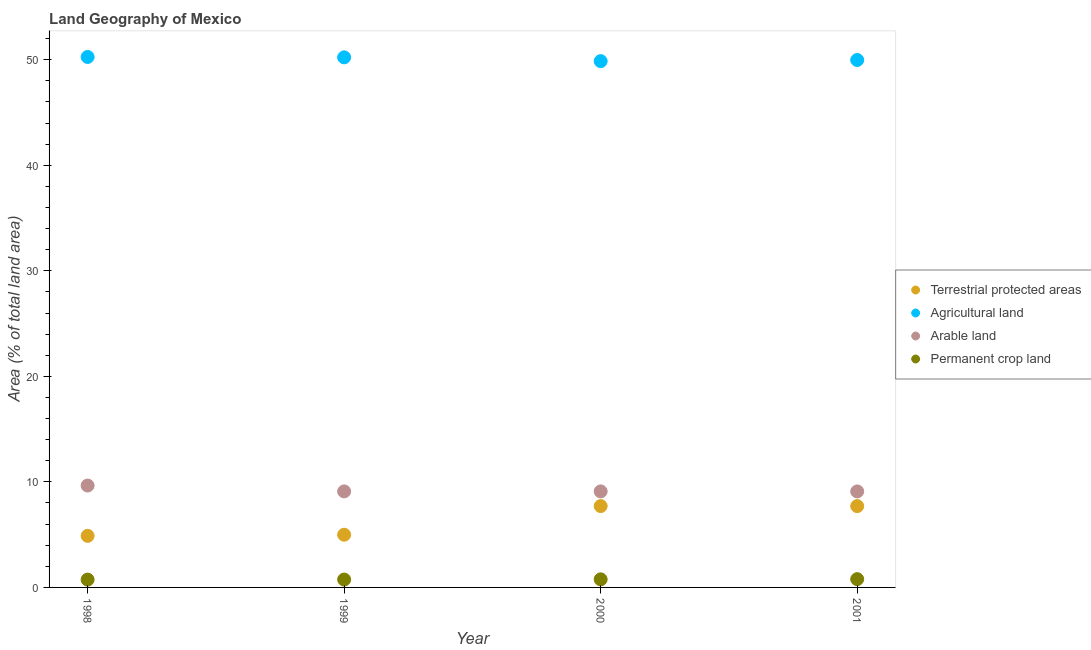How many different coloured dotlines are there?
Keep it short and to the point. 4. What is the percentage of area under agricultural land in 2001?
Provide a succinct answer. 49.98. Across all years, what is the maximum percentage of land under terrestrial protection?
Keep it short and to the point. 7.71. Across all years, what is the minimum percentage of land under terrestrial protection?
Offer a terse response. 4.89. What is the total percentage of area under permanent crop land in the graph?
Give a very brief answer. 3.04. What is the difference between the percentage of land under terrestrial protection in 1998 and that in 1999?
Your response must be concise. -0.11. What is the difference between the percentage of area under arable land in 1998 and the percentage of land under terrestrial protection in 2000?
Your response must be concise. 1.95. What is the average percentage of land under terrestrial protection per year?
Your response must be concise. 6.32. In the year 2000, what is the difference between the percentage of area under agricultural land and percentage of land under terrestrial protection?
Provide a succinct answer. 42.16. What is the ratio of the percentage of area under permanent crop land in 2000 to that in 2001?
Your answer should be very brief. 0.98. Is the percentage of land under terrestrial protection in 1998 less than that in 2001?
Your answer should be compact. Yes. What is the difference between the highest and the second highest percentage of area under arable land?
Your response must be concise. 0.56. What is the difference between the highest and the lowest percentage of area under agricultural land?
Provide a short and direct response. 0.4. In how many years, is the percentage of area under permanent crop land greater than the average percentage of area under permanent crop land taken over all years?
Give a very brief answer. 2. Is it the case that in every year, the sum of the percentage of area under permanent crop land and percentage of area under agricultural land is greater than the sum of percentage of land under terrestrial protection and percentage of area under arable land?
Provide a succinct answer. Yes. Is it the case that in every year, the sum of the percentage of land under terrestrial protection and percentage of area under agricultural land is greater than the percentage of area under arable land?
Provide a short and direct response. Yes. Does the percentage of land under terrestrial protection monotonically increase over the years?
Make the answer very short. No. Is the percentage of land under terrestrial protection strictly less than the percentage of area under permanent crop land over the years?
Ensure brevity in your answer.  No. How many dotlines are there?
Provide a short and direct response. 4. How many years are there in the graph?
Give a very brief answer. 4. What is the difference between two consecutive major ticks on the Y-axis?
Keep it short and to the point. 10. Are the values on the major ticks of Y-axis written in scientific E-notation?
Offer a very short reply. No. Does the graph contain any zero values?
Give a very brief answer. No. How are the legend labels stacked?
Keep it short and to the point. Vertical. What is the title of the graph?
Offer a very short reply. Land Geography of Mexico. What is the label or title of the X-axis?
Ensure brevity in your answer.  Year. What is the label or title of the Y-axis?
Provide a succinct answer. Area (% of total land area). What is the Area (% of total land area) in Terrestrial protected areas in 1998?
Offer a very short reply. 4.89. What is the Area (% of total land area) of Agricultural land in 1998?
Make the answer very short. 50.26. What is the Area (% of total land area) of Arable land in 1998?
Give a very brief answer. 9.66. What is the Area (% of total land area) of Permanent crop land in 1998?
Your response must be concise. 0.74. What is the Area (% of total land area) of Terrestrial protected areas in 1999?
Your answer should be very brief. 4.99. What is the Area (% of total land area) of Agricultural land in 1999?
Provide a succinct answer. 50.23. What is the Area (% of total land area) in Arable land in 1999?
Offer a very short reply. 9.1. What is the Area (% of total land area) of Permanent crop land in 1999?
Your answer should be very brief. 0.75. What is the Area (% of total land area) of Terrestrial protected areas in 2000?
Your answer should be very brief. 7.71. What is the Area (% of total land area) in Agricultural land in 2000?
Your answer should be very brief. 49.87. What is the Area (% of total land area) in Arable land in 2000?
Provide a succinct answer. 9.1. What is the Area (% of total land area) in Permanent crop land in 2000?
Ensure brevity in your answer.  0.77. What is the Area (% of total land area) of Terrestrial protected areas in 2001?
Provide a succinct answer. 7.7. What is the Area (% of total land area) in Agricultural land in 2001?
Make the answer very short. 49.98. What is the Area (% of total land area) of Arable land in 2001?
Offer a very short reply. 9.1. What is the Area (% of total land area) of Permanent crop land in 2001?
Provide a short and direct response. 0.78. Across all years, what is the maximum Area (% of total land area) in Terrestrial protected areas?
Provide a succinct answer. 7.71. Across all years, what is the maximum Area (% of total land area) in Agricultural land?
Ensure brevity in your answer.  50.26. Across all years, what is the maximum Area (% of total land area) of Arable land?
Provide a short and direct response. 9.66. Across all years, what is the maximum Area (% of total land area) in Permanent crop land?
Ensure brevity in your answer.  0.78. Across all years, what is the minimum Area (% of total land area) of Terrestrial protected areas?
Give a very brief answer. 4.89. Across all years, what is the minimum Area (% of total land area) of Agricultural land?
Offer a terse response. 49.87. Across all years, what is the minimum Area (% of total land area) in Arable land?
Offer a very short reply. 9.1. Across all years, what is the minimum Area (% of total land area) of Permanent crop land?
Your answer should be very brief. 0.74. What is the total Area (% of total land area) of Terrestrial protected areas in the graph?
Offer a terse response. 25.3. What is the total Area (% of total land area) in Agricultural land in the graph?
Your response must be concise. 200.33. What is the total Area (% of total land area) in Arable land in the graph?
Your answer should be very brief. 36.95. What is the total Area (% of total land area) of Permanent crop land in the graph?
Offer a terse response. 3.04. What is the difference between the Area (% of total land area) in Terrestrial protected areas in 1998 and that in 1999?
Your response must be concise. -0.11. What is the difference between the Area (% of total land area) of Agricultural land in 1998 and that in 1999?
Offer a terse response. 0.04. What is the difference between the Area (% of total land area) in Arable land in 1998 and that in 1999?
Ensure brevity in your answer.  0.56. What is the difference between the Area (% of total land area) of Permanent crop land in 1998 and that in 1999?
Ensure brevity in your answer.  -0.01. What is the difference between the Area (% of total land area) of Terrestrial protected areas in 1998 and that in 2000?
Make the answer very short. -2.82. What is the difference between the Area (% of total land area) of Agricultural land in 1998 and that in 2000?
Your response must be concise. 0.4. What is the difference between the Area (% of total land area) of Arable land in 1998 and that in 2000?
Make the answer very short. 0.56. What is the difference between the Area (% of total land area) in Permanent crop land in 1998 and that in 2000?
Make the answer very short. -0.03. What is the difference between the Area (% of total land area) of Terrestrial protected areas in 1998 and that in 2001?
Keep it short and to the point. -2.82. What is the difference between the Area (% of total land area) of Agricultural land in 1998 and that in 2001?
Your answer should be very brief. 0.29. What is the difference between the Area (% of total land area) in Arable land in 1998 and that in 2001?
Ensure brevity in your answer.  0.56. What is the difference between the Area (% of total land area) of Permanent crop land in 1998 and that in 2001?
Offer a terse response. -0.04. What is the difference between the Area (% of total land area) in Terrestrial protected areas in 1999 and that in 2000?
Keep it short and to the point. -2.72. What is the difference between the Area (% of total land area) of Agricultural land in 1999 and that in 2000?
Keep it short and to the point. 0.36. What is the difference between the Area (% of total land area) of Arable land in 1999 and that in 2000?
Offer a very short reply. -0. What is the difference between the Area (% of total land area) in Permanent crop land in 1999 and that in 2000?
Provide a short and direct response. -0.02. What is the difference between the Area (% of total land area) of Terrestrial protected areas in 1999 and that in 2001?
Make the answer very short. -2.71. What is the difference between the Area (% of total land area) in Agricultural land in 1999 and that in 2001?
Your response must be concise. 0.25. What is the difference between the Area (% of total land area) of Arable land in 1999 and that in 2001?
Offer a very short reply. 0. What is the difference between the Area (% of total land area) of Permanent crop land in 1999 and that in 2001?
Your answer should be very brief. -0.04. What is the difference between the Area (% of total land area) in Terrestrial protected areas in 2000 and that in 2001?
Your response must be concise. 0.01. What is the difference between the Area (% of total land area) in Agricultural land in 2000 and that in 2001?
Give a very brief answer. -0.11. What is the difference between the Area (% of total land area) in Arable land in 2000 and that in 2001?
Make the answer very short. 0. What is the difference between the Area (% of total land area) in Permanent crop land in 2000 and that in 2001?
Make the answer very short. -0.02. What is the difference between the Area (% of total land area) of Terrestrial protected areas in 1998 and the Area (% of total land area) of Agricultural land in 1999?
Keep it short and to the point. -45.34. What is the difference between the Area (% of total land area) in Terrestrial protected areas in 1998 and the Area (% of total land area) in Arable land in 1999?
Offer a terse response. -4.21. What is the difference between the Area (% of total land area) of Terrestrial protected areas in 1998 and the Area (% of total land area) of Permanent crop land in 1999?
Offer a very short reply. 4.14. What is the difference between the Area (% of total land area) of Agricultural land in 1998 and the Area (% of total land area) of Arable land in 1999?
Offer a very short reply. 41.16. What is the difference between the Area (% of total land area) of Agricultural land in 1998 and the Area (% of total land area) of Permanent crop land in 1999?
Provide a succinct answer. 49.52. What is the difference between the Area (% of total land area) of Arable land in 1998 and the Area (% of total land area) of Permanent crop land in 1999?
Offer a terse response. 8.91. What is the difference between the Area (% of total land area) in Terrestrial protected areas in 1998 and the Area (% of total land area) in Agricultural land in 2000?
Provide a succinct answer. -44.98. What is the difference between the Area (% of total land area) in Terrestrial protected areas in 1998 and the Area (% of total land area) in Arable land in 2000?
Give a very brief answer. -4.21. What is the difference between the Area (% of total land area) of Terrestrial protected areas in 1998 and the Area (% of total land area) of Permanent crop land in 2000?
Provide a succinct answer. 4.12. What is the difference between the Area (% of total land area) of Agricultural land in 1998 and the Area (% of total land area) of Arable land in 2000?
Keep it short and to the point. 41.16. What is the difference between the Area (% of total land area) in Agricultural land in 1998 and the Area (% of total land area) in Permanent crop land in 2000?
Offer a terse response. 49.5. What is the difference between the Area (% of total land area) of Arable land in 1998 and the Area (% of total land area) of Permanent crop land in 2000?
Provide a short and direct response. 8.89. What is the difference between the Area (% of total land area) in Terrestrial protected areas in 1998 and the Area (% of total land area) in Agricultural land in 2001?
Ensure brevity in your answer.  -45.09. What is the difference between the Area (% of total land area) in Terrestrial protected areas in 1998 and the Area (% of total land area) in Arable land in 2001?
Your response must be concise. -4.21. What is the difference between the Area (% of total land area) in Terrestrial protected areas in 1998 and the Area (% of total land area) in Permanent crop land in 2001?
Offer a very short reply. 4.1. What is the difference between the Area (% of total land area) of Agricultural land in 1998 and the Area (% of total land area) of Arable land in 2001?
Provide a succinct answer. 41.17. What is the difference between the Area (% of total land area) in Agricultural land in 1998 and the Area (% of total land area) in Permanent crop land in 2001?
Your response must be concise. 49.48. What is the difference between the Area (% of total land area) of Arable land in 1998 and the Area (% of total land area) of Permanent crop land in 2001?
Give a very brief answer. 8.87. What is the difference between the Area (% of total land area) of Terrestrial protected areas in 1999 and the Area (% of total land area) of Agricultural land in 2000?
Make the answer very short. -44.87. What is the difference between the Area (% of total land area) in Terrestrial protected areas in 1999 and the Area (% of total land area) in Arable land in 2000?
Your answer should be very brief. -4.11. What is the difference between the Area (% of total land area) in Terrestrial protected areas in 1999 and the Area (% of total land area) in Permanent crop land in 2000?
Offer a terse response. 4.23. What is the difference between the Area (% of total land area) in Agricultural land in 1999 and the Area (% of total land area) in Arable land in 2000?
Offer a very short reply. 41.13. What is the difference between the Area (% of total land area) in Agricultural land in 1999 and the Area (% of total land area) in Permanent crop land in 2000?
Keep it short and to the point. 49.46. What is the difference between the Area (% of total land area) in Arable land in 1999 and the Area (% of total land area) in Permanent crop land in 2000?
Keep it short and to the point. 8.33. What is the difference between the Area (% of total land area) of Terrestrial protected areas in 1999 and the Area (% of total land area) of Agricultural land in 2001?
Offer a very short reply. -44.98. What is the difference between the Area (% of total land area) of Terrestrial protected areas in 1999 and the Area (% of total land area) of Arable land in 2001?
Ensure brevity in your answer.  -4.1. What is the difference between the Area (% of total land area) in Terrestrial protected areas in 1999 and the Area (% of total land area) in Permanent crop land in 2001?
Keep it short and to the point. 4.21. What is the difference between the Area (% of total land area) of Agricultural land in 1999 and the Area (% of total land area) of Arable land in 2001?
Your answer should be compact. 41.13. What is the difference between the Area (% of total land area) in Agricultural land in 1999 and the Area (% of total land area) in Permanent crop land in 2001?
Your answer should be very brief. 49.44. What is the difference between the Area (% of total land area) of Arable land in 1999 and the Area (% of total land area) of Permanent crop land in 2001?
Give a very brief answer. 8.31. What is the difference between the Area (% of total land area) of Terrestrial protected areas in 2000 and the Area (% of total land area) of Agricultural land in 2001?
Your response must be concise. -42.27. What is the difference between the Area (% of total land area) of Terrestrial protected areas in 2000 and the Area (% of total land area) of Arable land in 2001?
Offer a very short reply. -1.39. What is the difference between the Area (% of total land area) in Terrestrial protected areas in 2000 and the Area (% of total land area) in Permanent crop land in 2001?
Your answer should be very brief. 6.93. What is the difference between the Area (% of total land area) of Agricultural land in 2000 and the Area (% of total land area) of Arable land in 2001?
Offer a terse response. 40.77. What is the difference between the Area (% of total land area) of Agricultural land in 2000 and the Area (% of total land area) of Permanent crop land in 2001?
Offer a very short reply. 49.08. What is the difference between the Area (% of total land area) in Arable land in 2000 and the Area (% of total land area) in Permanent crop land in 2001?
Your response must be concise. 8.31. What is the average Area (% of total land area) of Terrestrial protected areas per year?
Offer a terse response. 6.32. What is the average Area (% of total land area) of Agricultural land per year?
Provide a succinct answer. 50.08. What is the average Area (% of total land area) in Arable land per year?
Your answer should be very brief. 9.24. What is the average Area (% of total land area) of Permanent crop land per year?
Offer a terse response. 0.76. In the year 1998, what is the difference between the Area (% of total land area) in Terrestrial protected areas and Area (% of total land area) in Agricultural land?
Give a very brief answer. -45.38. In the year 1998, what is the difference between the Area (% of total land area) in Terrestrial protected areas and Area (% of total land area) in Arable land?
Offer a terse response. -4.77. In the year 1998, what is the difference between the Area (% of total land area) of Terrestrial protected areas and Area (% of total land area) of Permanent crop land?
Give a very brief answer. 4.15. In the year 1998, what is the difference between the Area (% of total land area) in Agricultural land and Area (% of total land area) in Arable land?
Keep it short and to the point. 40.61. In the year 1998, what is the difference between the Area (% of total land area) of Agricultural land and Area (% of total land area) of Permanent crop land?
Your answer should be compact. 49.52. In the year 1998, what is the difference between the Area (% of total land area) in Arable land and Area (% of total land area) in Permanent crop land?
Offer a terse response. 8.91. In the year 1999, what is the difference between the Area (% of total land area) in Terrestrial protected areas and Area (% of total land area) in Agricultural land?
Provide a short and direct response. -45.23. In the year 1999, what is the difference between the Area (% of total land area) of Terrestrial protected areas and Area (% of total land area) of Arable land?
Ensure brevity in your answer.  -4.11. In the year 1999, what is the difference between the Area (% of total land area) in Terrestrial protected areas and Area (% of total land area) in Permanent crop land?
Provide a succinct answer. 4.25. In the year 1999, what is the difference between the Area (% of total land area) of Agricultural land and Area (% of total land area) of Arable land?
Provide a short and direct response. 41.13. In the year 1999, what is the difference between the Area (% of total land area) of Agricultural land and Area (% of total land area) of Permanent crop land?
Keep it short and to the point. 49.48. In the year 1999, what is the difference between the Area (% of total land area) in Arable land and Area (% of total land area) in Permanent crop land?
Keep it short and to the point. 8.35. In the year 2000, what is the difference between the Area (% of total land area) of Terrestrial protected areas and Area (% of total land area) of Agricultural land?
Provide a succinct answer. -42.16. In the year 2000, what is the difference between the Area (% of total land area) of Terrestrial protected areas and Area (% of total land area) of Arable land?
Provide a succinct answer. -1.39. In the year 2000, what is the difference between the Area (% of total land area) of Terrestrial protected areas and Area (% of total land area) of Permanent crop land?
Provide a short and direct response. 6.94. In the year 2000, what is the difference between the Area (% of total land area) in Agricultural land and Area (% of total land area) in Arable land?
Keep it short and to the point. 40.77. In the year 2000, what is the difference between the Area (% of total land area) in Agricultural land and Area (% of total land area) in Permanent crop land?
Provide a short and direct response. 49.1. In the year 2000, what is the difference between the Area (% of total land area) of Arable land and Area (% of total land area) of Permanent crop land?
Ensure brevity in your answer.  8.33. In the year 2001, what is the difference between the Area (% of total land area) of Terrestrial protected areas and Area (% of total land area) of Agricultural land?
Ensure brevity in your answer.  -42.27. In the year 2001, what is the difference between the Area (% of total land area) in Terrestrial protected areas and Area (% of total land area) in Arable land?
Your answer should be compact. -1.39. In the year 2001, what is the difference between the Area (% of total land area) in Terrestrial protected areas and Area (% of total land area) in Permanent crop land?
Ensure brevity in your answer.  6.92. In the year 2001, what is the difference between the Area (% of total land area) in Agricultural land and Area (% of total land area) in Arable land?
Your response must be concise. 40.88. In the year 2001, what is the difference between the Area (% of total land area) of Agricultural land and Area (% of total land area) of Permanent crop land?
Give a very brief answer. 49.19. In the year 2001, what is the difference between the Area (% of total land area) in Arable land and Area (% of total land area) in Permanent crop land?
Your response must be concise. 8.31. What is the ratio of the Area (% of total land area) in Terrestrial protected areas in 1998 to that in 1999?
Your answer should be compact. 0.98. What is the ratio of the Area (% of total land area) in Agricultural land in 1998 to that in 1999?
Your response must be concise. 1. What is the ratio of the Area (% of total land area) in Arable land in 1998 to that in 1999?
Your answer should be compact. 1.06. What is the ratio of the Area (% of total land area) in Terrestrial protected areas in 1998 to that in 2000?
Offer a very short reply. 0.63. What is the ratio of the Area (% of total land area) of Agricultural land in 1998 to that in 2000?
Ensure brevity in your answer.  1.01. What is the ratio of the Area (% of total land area) in Arable land in 1998 to that in 2000?
Make the answer very short. 1.06. What is the ratio of the Area (% of total land area) of Permanent crop land in 1998 to that in 2000?
Your answer should be very brief. 0.97. What is the ratio of the Area (% of total land area) in Terrestrial protected areas in 1998 to that in 2001?
Make the answer very short. 0.63. What is the ratio of the Area (% of total land area) of Arable land in 1998 to that in 2001?
Give a very brief answer. 1.06. What is the ratio of the Area (% of total land area) of Permanent crop land in 1998 to that in 2001?
Offer a very short reply. 0.94. What is the ratio of the Area (% of total land area) of Terrestrial protected areas in 1999 to that in 2000?
Your answer should be compact. 0.65. What is the ratio of the Area (% of total land area) of Permanent crop land in 1999 to that in 2000?
Keep it short and to the point. 0.97. What is the ratio of the Area (% of total land area) in Terrestrial protected areas in 1999 to that in 2001?
Your answer should be very brief. 0.65. What is the ratio of the Area (% of total land area) of Permanent crop land in 1999 to that in 2001?
Provide a short and direct response. 0.95. What is the ratio of the Area (% of total land area) in Arable land in 2000 to that in 2001?
Provide a short and direct response. 1. What is the ratio of the Area (% of total land area) of Permanent crop land in 2000 to that in 2001?
Keep it short and to the point. 0.98. What is the difference between the highest and the second highest Area (% of total land area) of Terrestrial protected areas?
Provide a succinct answer. 0.01. What is the difference between the highest and the second highest Area (% of total land area) in Agricultural land?
Provide a short and direct response. 0.04. What is the difference between the highest and the second highest Area (% of total land area) of Arable land?
Your response must be concise. 0.56. What is the difference between the highest and the second highest Area (% of total land area) of Permanent crop land?
Keep it short and to the point. 0.02. What is the difference between the highest and the lowest Area (% of total land area) in Terrestrial protected areas?
Provide a short and direct response. 2.82. What is the difference between the highest and the lowest Area (% of total land area) of Agricultural land?
Provide a succinct answer. 0.4. What is the difference between the highest and the lowest Area (% of total land area) of Arable land?
Provide a short and direct response. 0.56. What is the difference between the highest and the lowest Area (% of total land area) in Permanent crop land?
Offer a terse response. 0.04. 